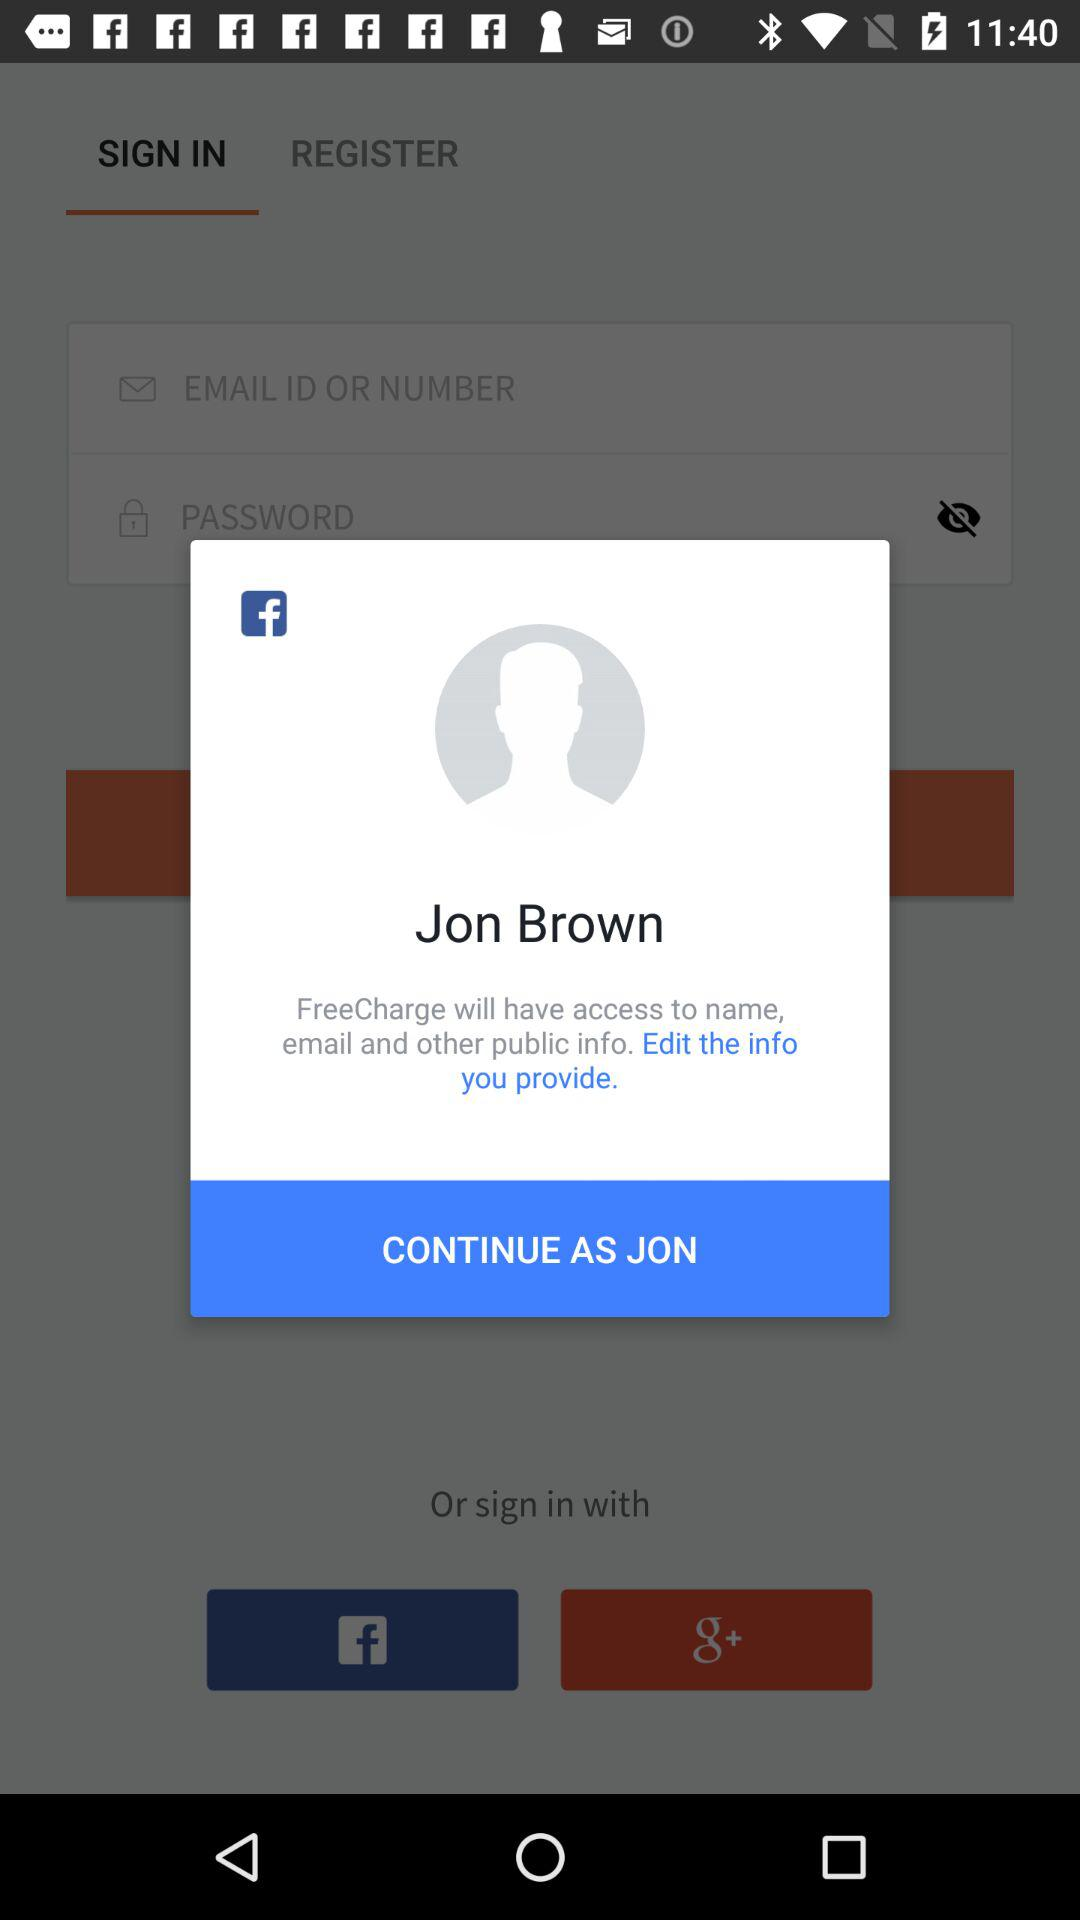What is the login name? The login name is Jon Brown. 